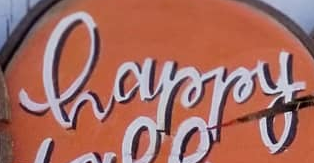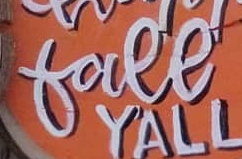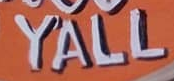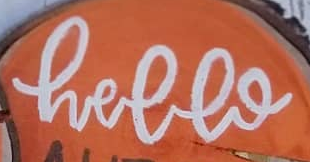Transcribe the words shown in these images in order, separated by a semicolon. happy; free; YALL; hello 